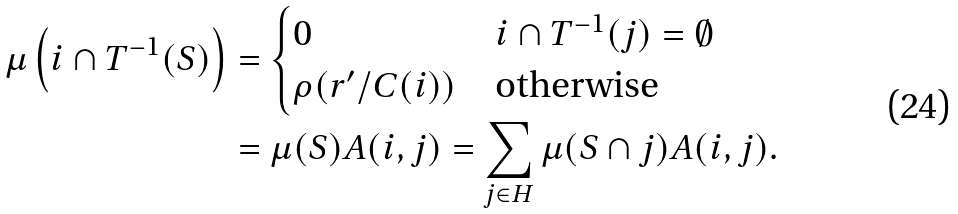Convert formula to latex. <formula><loc_0><loc_0><loc_500><loc_500>\mu \left ( i \cap T ^ { - 1 } ( S ) \right ) & = \begin{cases} 0 & i \cap T ^ { - 1 } ( j ) = \emptyset \\ \rho ( r ^ { \prime } / C ( i ) ) & \text {otherwise} \end{cases} \\ & = \mu ( S ) A ( i , j ) = \sum _ { j \in H } \mu ( S \cap j ) A ( i , j ) .</formula> 